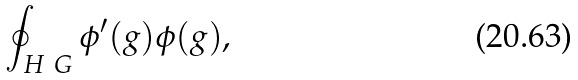<formula> <loc_0><loc_0><loc_500><loc_500>\oint _ { H \ G } \phi ^ { \prime } ( g ) \phi ( g ) ,</formula> 